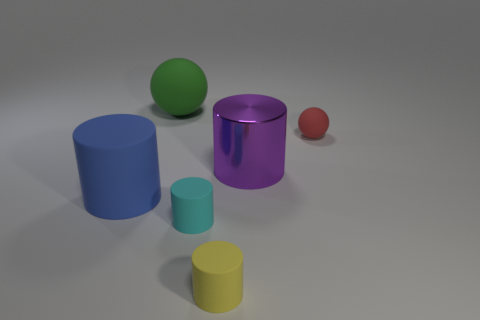Does the small red object to the right of the green matte thing have the same material as the big purple thing?
Your answer should be compact. No. Are there any purple shiny cylinders in front of the large blue cylinder?
Keep it short and to the point. No. There is a yellow cylinder right of the cyan rubber cylinder; does it have the same size as the rubber ball that is to the right of the green rubber ball?
Provide a succinct answer. Yes. Is there a cylinder of the same size as the purple metal object?
Give a very brief answer. Yes. There is a large matte thing in front of the small red object; is its shape the same as the red object?
Ensure brevity in your answer.  No. What is the big cylinder that is on the right side of the small yellow rubber object made of?
Ensure brevity in your answer.  Metal. What shape is the big matte thing in front of the big object on the right side of the small yellow rubber object?
Offer a very short reply. Cylinder. Is the shape of the big green thing the same as the small thing that is behind the small cyan rubber cylinder?
Provide a succinct answer. Yes. There is a large object that is behind the tiny red sphere; how many large things are in front of it?
Offer a very short reply. 2. There is another yellow thing that is the same shape as the shiny thing; what material is it?
Your response must be concise. Rubber. 